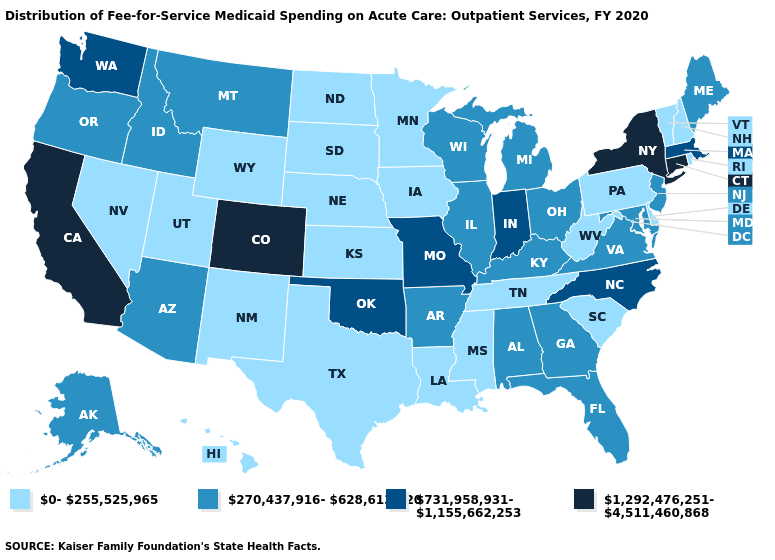Which states hav the highest value in the South?
Quick response, please. North Carolina, Oklahoma. What is the value of Arizona?
Give a very brief answer. 270,437,916-628,613,520. What is the highest value in the USA?
Short answer required. 1,292,476,251-4,511,460,868. Which states have the lowest value in the USA?
Answer briefly. Delaware, Hawaii, Iowa, Kansas, Louisiana, Minnesota, Mississippi, Nebraska, Nevada, New Hampshire, New Mexico, North Dakota, Pennsylvania, Rhode Island, South Carolina, South Dakota, Tennessee, Texas, Utah, Vermont, West Virginia, Wyoming. Name the states that have a value in the range 0-255,525,965?
Give a very brief answer. Delaware, Hawaii, Iowa, Kansas, Louisiana, Minnesota, Mississippi, Nebraska, Nevada, New Hampshire, New Mexico, North Dakota, Pennsylvania, Rhode Island, South Carolina, South Dakota, Tennessee, Texas, Utah, Vermont, West Virginia, Wyoming. Which states have the lowest value in the USA?
Quick response, please. Delaware, Hawaii, Iowa, Kansas, Louisiana, Minnesota, Mississippi, Nebraska, Nevada, New Hampshire, New Mexico, North Dakota, Pennsylvania, Rhode Island, South Carolina, South Dakota, Tennessee, Texas, Utah, Vermont, West Virginia, Wyoming. Does the first symbol in the legend represent the smallest category?
Write a very short answer. Yes. Is the legend a continuous bar?
Keep it brief. No. Name the states that have a value in the range 731,958,931-1,155,662,253?
Short answer required. Indiana, Massachusetts, Missouri, North Carolina, Oklahoma, Washington. Does Vermont have the highest value in the USA?
Keep it brief. No. What is the value of Kentucky?
Write a very short answer. 270,437,916-628,613,520. Does Indiana have a lower value than Georgia?
Give a very brief answer. No. Among the states that border Arkansas , does Oklahoma have the highest value?
Quick response, please. Yes. What is the value of Tennessee?
Concise answer only. 0-255,525,965. Is the legend a continuous bar?
Write a very short answer. No. 